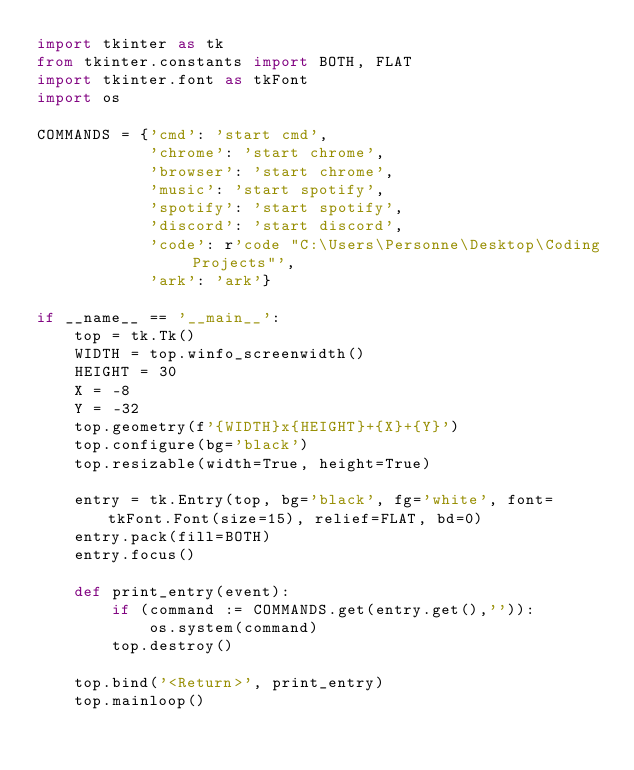<code> <loc_0><loc_0><loc_500><loc_500><_Python_>import tkinter as tk
from tkinter.constants import BOTH, FLAT
import tkinter.font as tkFont
import os

COMMANDS = {'cmd': 'start cmd',
            'chrome': 'start chrome',
            'browser': 'start chrome',
            'music': 'start spotify',
            'spotify': 'start spotify',
            'discord': 'start discord',
            'code': r'code "C:\Users\Personne\Desktop\Coding Projects"',
            'ark': 'ark'}

if __name__ == '__main__':
    top = tk.Tk()
    WIDTH = top.winfo_screenwidth()
    HEIGHT = 30
    X = -8
    Y = -32
    top.geometry(f'{WIDTH}x{HEIGHT}+{X}+{Y}')
    top.configure(bg='black')
    top.resizable(width=True, height=True)
    
    entry = tk.Entry(top, bg='black', fg='white', font=tkFont.Font(size=15), relief=FLAT, bd=0)
    entry.pack(fill=BOTH)
    entry.focus()
    
    def print_entry(event):
        if (command := COMMANDS.get(entry.get(),'')):
            os.system(command)
        top.destroy()
    
    top.bind('<Return>', print_entry)
    top.mainloop()</code> 